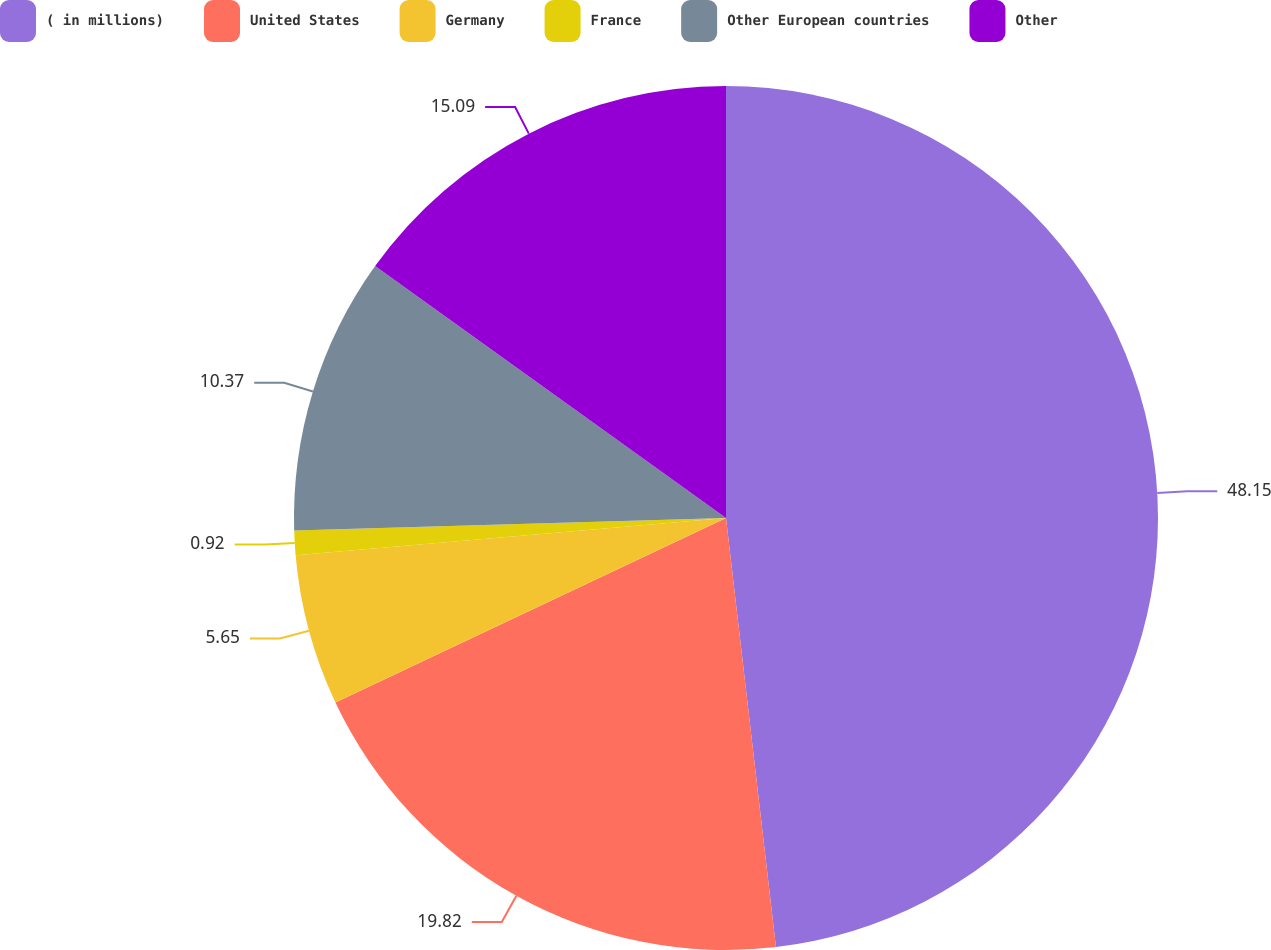Convert chart. <chart><loc_0><loc_0><loc_500><loc_500><pie_chart><fcel>( in millions)<fcel>United States<fcel>Germany<fcel>France<fcel>Other European countries<fcel>Other<nl><fcel>48.16%<fcel>19.82%<fcel>5.65%<fcel>0.92%<fcel>10.37%<fcel>15.09%<nl></chart> 